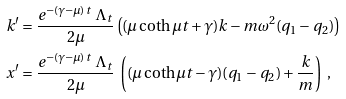<formula> <loc_0><loc_0><loc_500><loc_500>k ^ { \prime } & = \frac { e ^ { - ( \gamma - \mu ) t } \ \Lambda _ { t } } { 2 \mu } \left ( ( \mu \coth \mu t + \gamma ) k - m \omega ^ { 2 } ( q _ { 1 } - q _ { 2 } ) \right ) \\ x ^ { \prime } & = \frac { e ^ { - ( \gamma - \mu ) t } \ \Lambda _ { t } } { 2 \mu } \ \left ( ( \mu \coth \mu t - \gamma ) ( q _ { 1 } - q _ { 2 } ) + \frac { k } { m } \right ) \ ,</formula> 